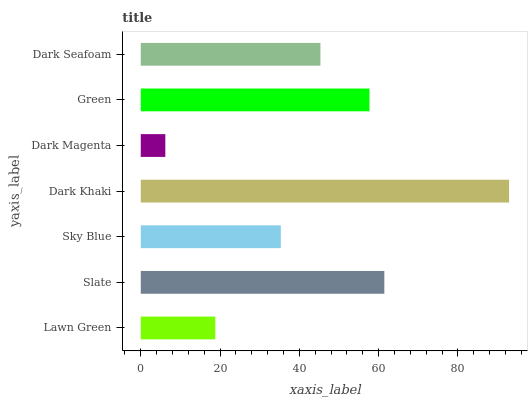Is Dark Magenta the minimum?
Answer yes or no. Yes. Is Dark Khaki the maximum?
Answer yes or no. Yes. Is Slate the minimum?
Answer yes or no. No. Is Slate the maximum?
Answer yes or no. No. Is Slate greater than Lawn Green?
Answer yes or no. Yes. Is Lawn Green less than Slate?
Answer yes or no. Yes. Is Lawn Green greater than Slate?
Answer yes or no. No. Is Slate less than Lawn Green?
Answer yes or no. No. Is Dark Seafoam the high median?
Answer yes or no. Yes. Is Dark Seafoam the low median?
Answer yes or no. Yes. Is Lawn Green the high median?
Answer yes or no. No. Is Green the low median?
Answer yes or no. No. 